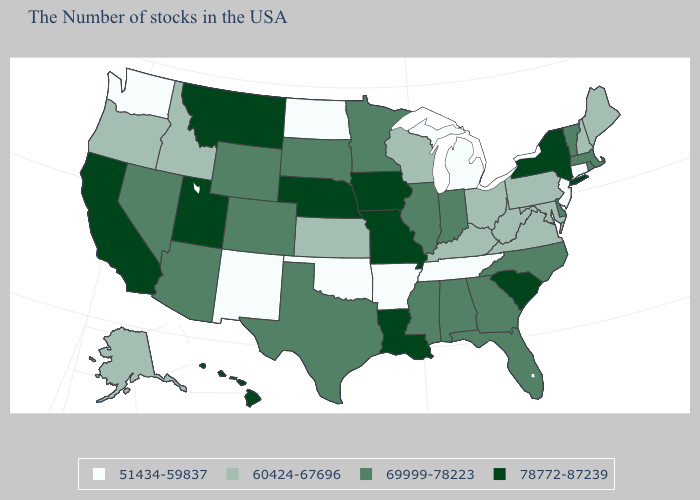What is the value of Michigan?
Keep it brief. 51434-59837. Name the states that have a value in the range 69999-78223?
Short answer required. Massachusetts, Rhode Island, Vermont, Delaware, North Carolina, Florida, Georgia, Indiana, Alabama, Illinois, Mississippi, Minnesota, Texas, South Dakota, Wyoming, Colorado, Arizona, Nevada. What is the value of Nevada?
Answer briefly. 69999-78223. How many symbols are there in the legend?
Short answer required. 4. Among the states that border Virginia , does North Carolina have the lowest value?
Give a very brief answer. No. Does Alaska have the lowest value in the USA?
Concise answer only. No. What is the value of Illinois?
Concise answer only. 69999-78223. What is the lowest value in the MidWest?
Give a very brief answer. 51434-59837. What is the highest value in states that border Maine?
Concise answer only. 60424-67696. What is the lowest value in the USA?
Concise answer only. 51434-59837. Does New Jersey have a higher value than Kentucky?
Short answer required. No. Does Indiana have the highest value in the MidWest?
Concise answer only. No. How many symbols are there in the legend?
Short answer required. 4. What is the value of Alaska?
Be succinct. 60424-67696. What is the lowest value in the USA?
Write a very short answer. 51434-59837. 